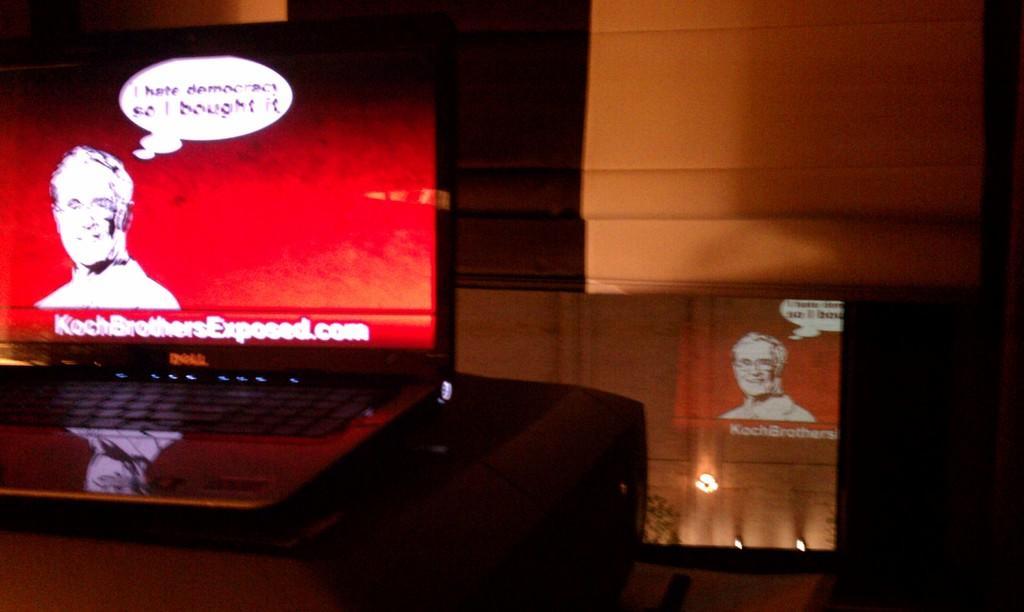In one or two sentences, can you explain what this image depicts? In this image I can see a laptop in the front and on its screen I can see something is written. In the background I can see few lights and I can see this image is little bit in dark. 